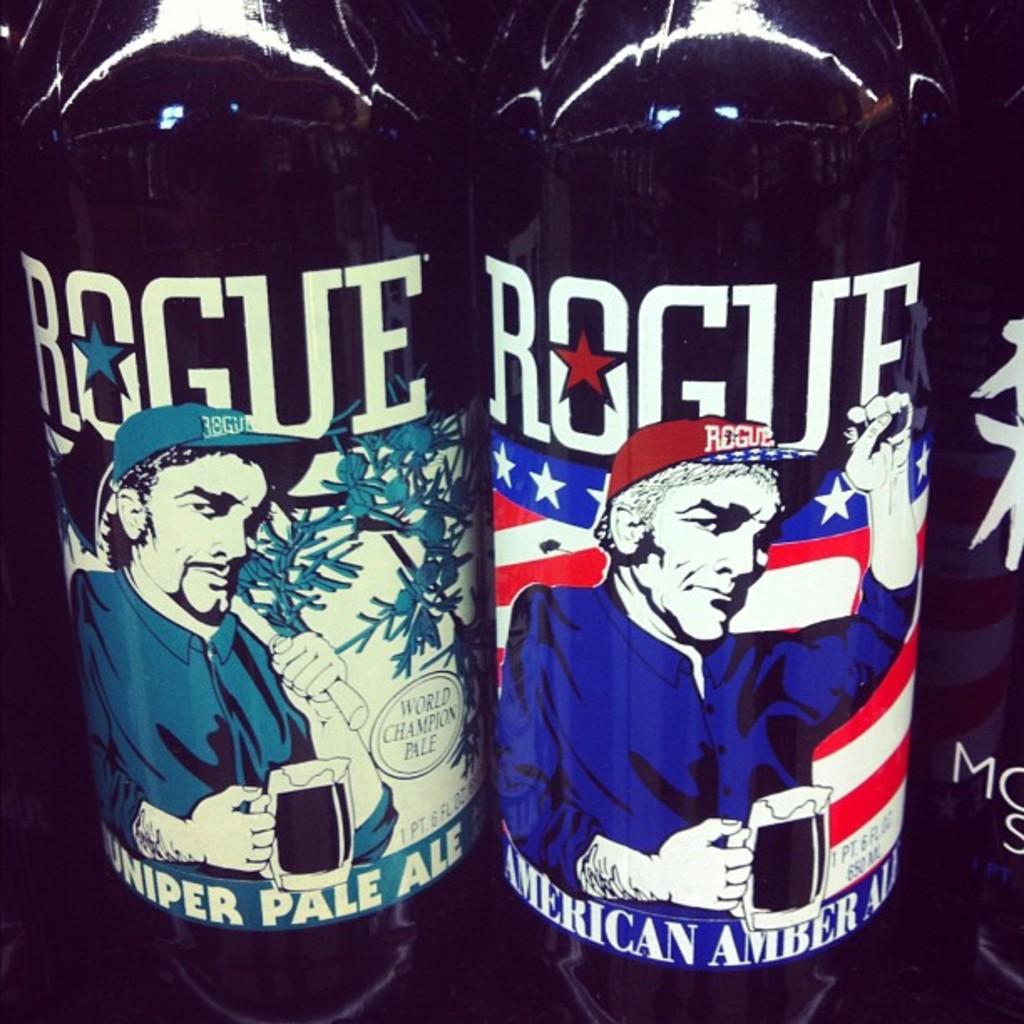What brand of beer is it?
Keep it short and to the point. Rogue. Which two types of ales are these?
Provide a succinct answer. Juniper pale ale, american amber ale. 